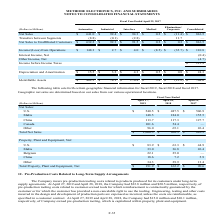According to Methode Electronics's financial document, What were the net sales in Malta in 2019? According to the financial document, 148.5 (in millions). The relevant text states: "Malta 148.5 184.0 155.5..." Also, What were the net sales in U.S. in 2018? According to the financial document, $487.5 (in millions). The relevant text states: "U.S. $ 540.5 $ 487.5 $ 506.9..." Also, What were the net sales in U.S. in 2019? According to the financial document, $540.5 (in millions). The relevant text states: "U.S. $ 540.5 $ 487.5 $ 506.9..." Also, can you calculate: What was the change in the net sales from U.S. from 2018 to 2019? Based on the calculation: 540.5 - 487.5, the result is 53 (in millions). This is based on the information: "U.S. $ 540.5 $ 487.5 $ 506.9 U.S. $ 540.5 $ 487.5 $ 506.9..." The key data points involved are: 487.5, 540.5. Also, can you calculate: What was the average net sales from Malta for 2017-2019? To answer this question, I need to perform calculations using the financial data. The calculation is: (148.5 + 184.0 + 155.5) / 3, which equals 162.67 (in millions). This is based on the information: "Malta 148.5 184.0 155.5 Malta 148.5 184.0 155.5 Malta 148.5 184.0 155.5..." The key data points involved are: 148.5, 155.5, 184.0. Additionally, In which year was Total Net Sales less than 1,000.0 million? The document shows two values: 2018 and 2017. Locate and analyze total net sales in row 10. From the document: "Fiscal Year Ended April 29, 2017 hic financial information for fiscal 2019, fiscal 2018 and fiscal 2017...." 